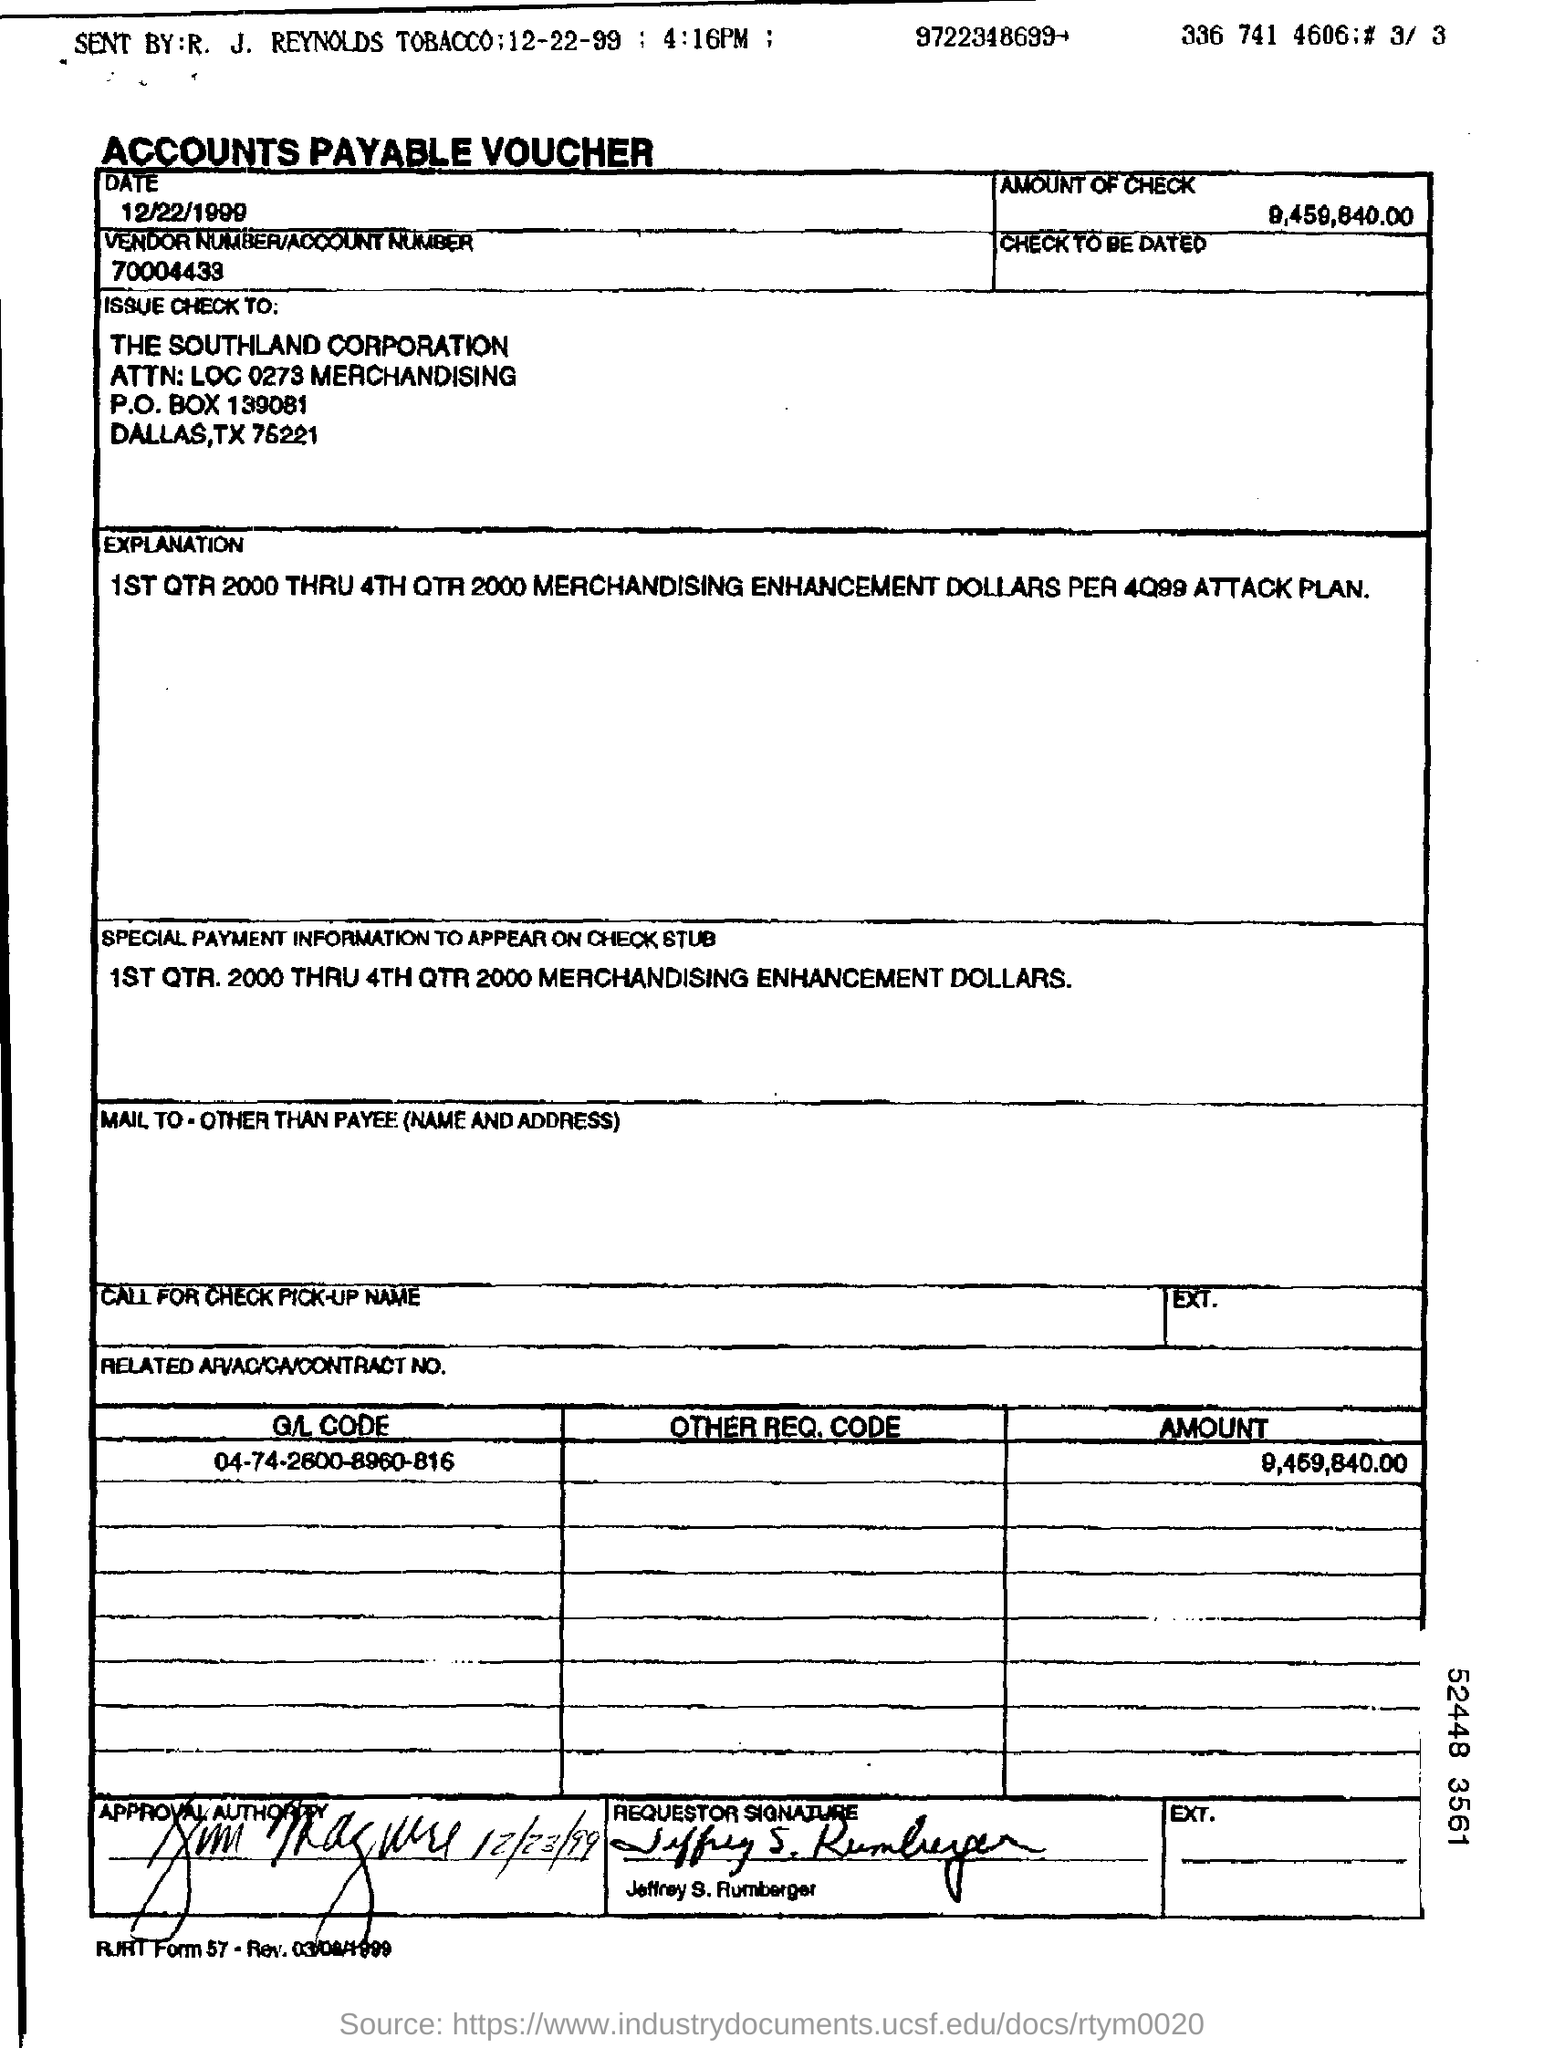What is the amount of check mentioned in the voucher?
Provide a succinct answer. 9,459,840.00. What is the vendor number/account number mentioned in the voucher?
Provide a succinct answer. 70004433. What is the vendor no/account no mentioned in the voucher?
Your answer should be compact. 70004433. To which company , the check is issued to?
Provide a succinct answer. THE SOUTHLAND CORPORATION. What type of voucher is given here?
Provide a succinct answer. ACCOUNTS PAYABLE VOUCHER. Who is the requestor as given in the voucher?
Ensure brevity in your answer.  Jeffrey S. Rumberger. 